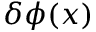<formula> <loc_0><loc_0><loc_500><loc_500>\delta \phi ( x )</formula> 